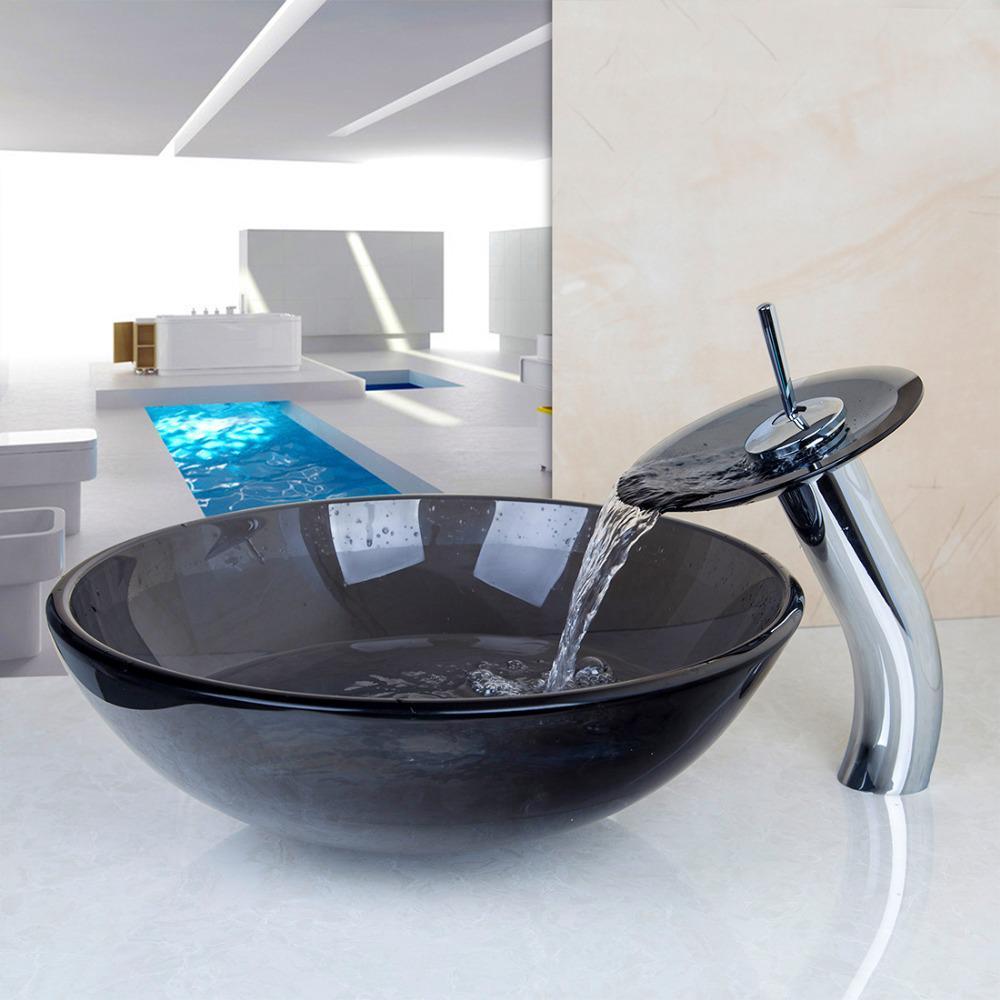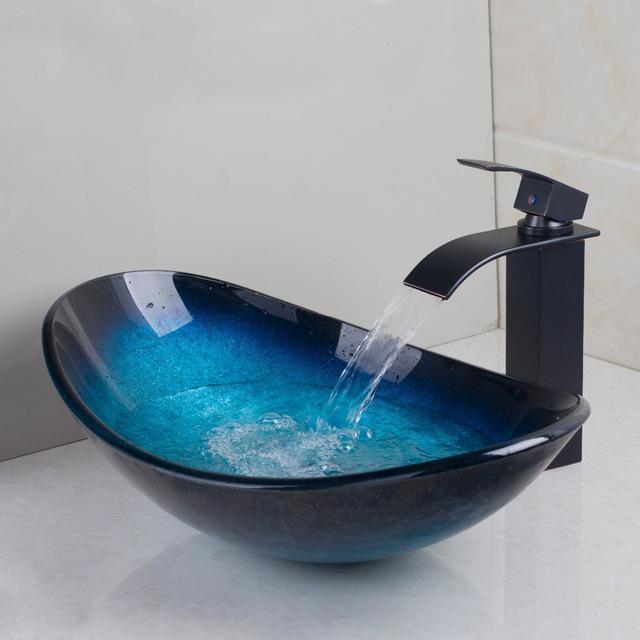The first image is the image on the left, the second image is the image on the right. For the images displayed, is the sentence "The bowl in each pair is the same color" factually correct? Answer yes or no. Yes. The first image is the image on the left, the second image is the image on the right. Examine the images to the left and right. Is the description "At least one image contains a transparent wash basin." accurate? Answer yes or no. No. 